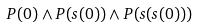<formula> <loc_0><loc_0><loc_500><loc_500>P ( 0 ) \wedge P ( s ( 0 ) ) \wedge P ( s ( s ( 0 ) ) )</formula> 